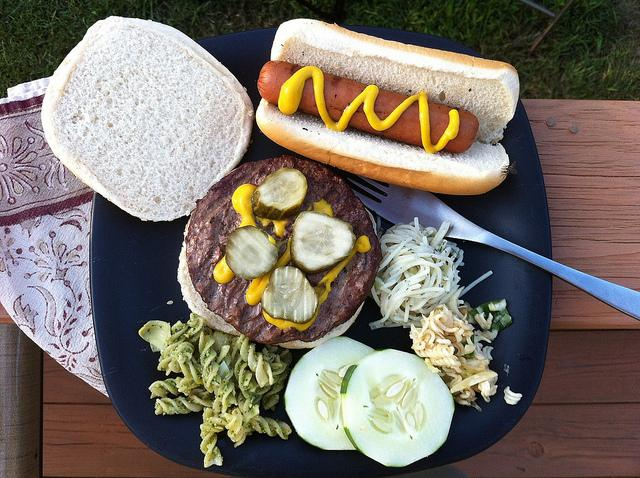How were the meats most likely cooked? grilled 